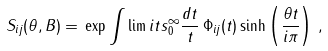Convert formula to latex. <formula><loc_0><loc_0><loc_500><loc_500>S _ { i j } ( \theta , B ) = \, \exp \int \lim i t s _ { 0 } ^ { \infty } \frac { d t } { t } \, \Phi _ { i j } ( t ) \sinh \left ( \frac { \theta t } { i \pi } \right ) \, ,</formula> 